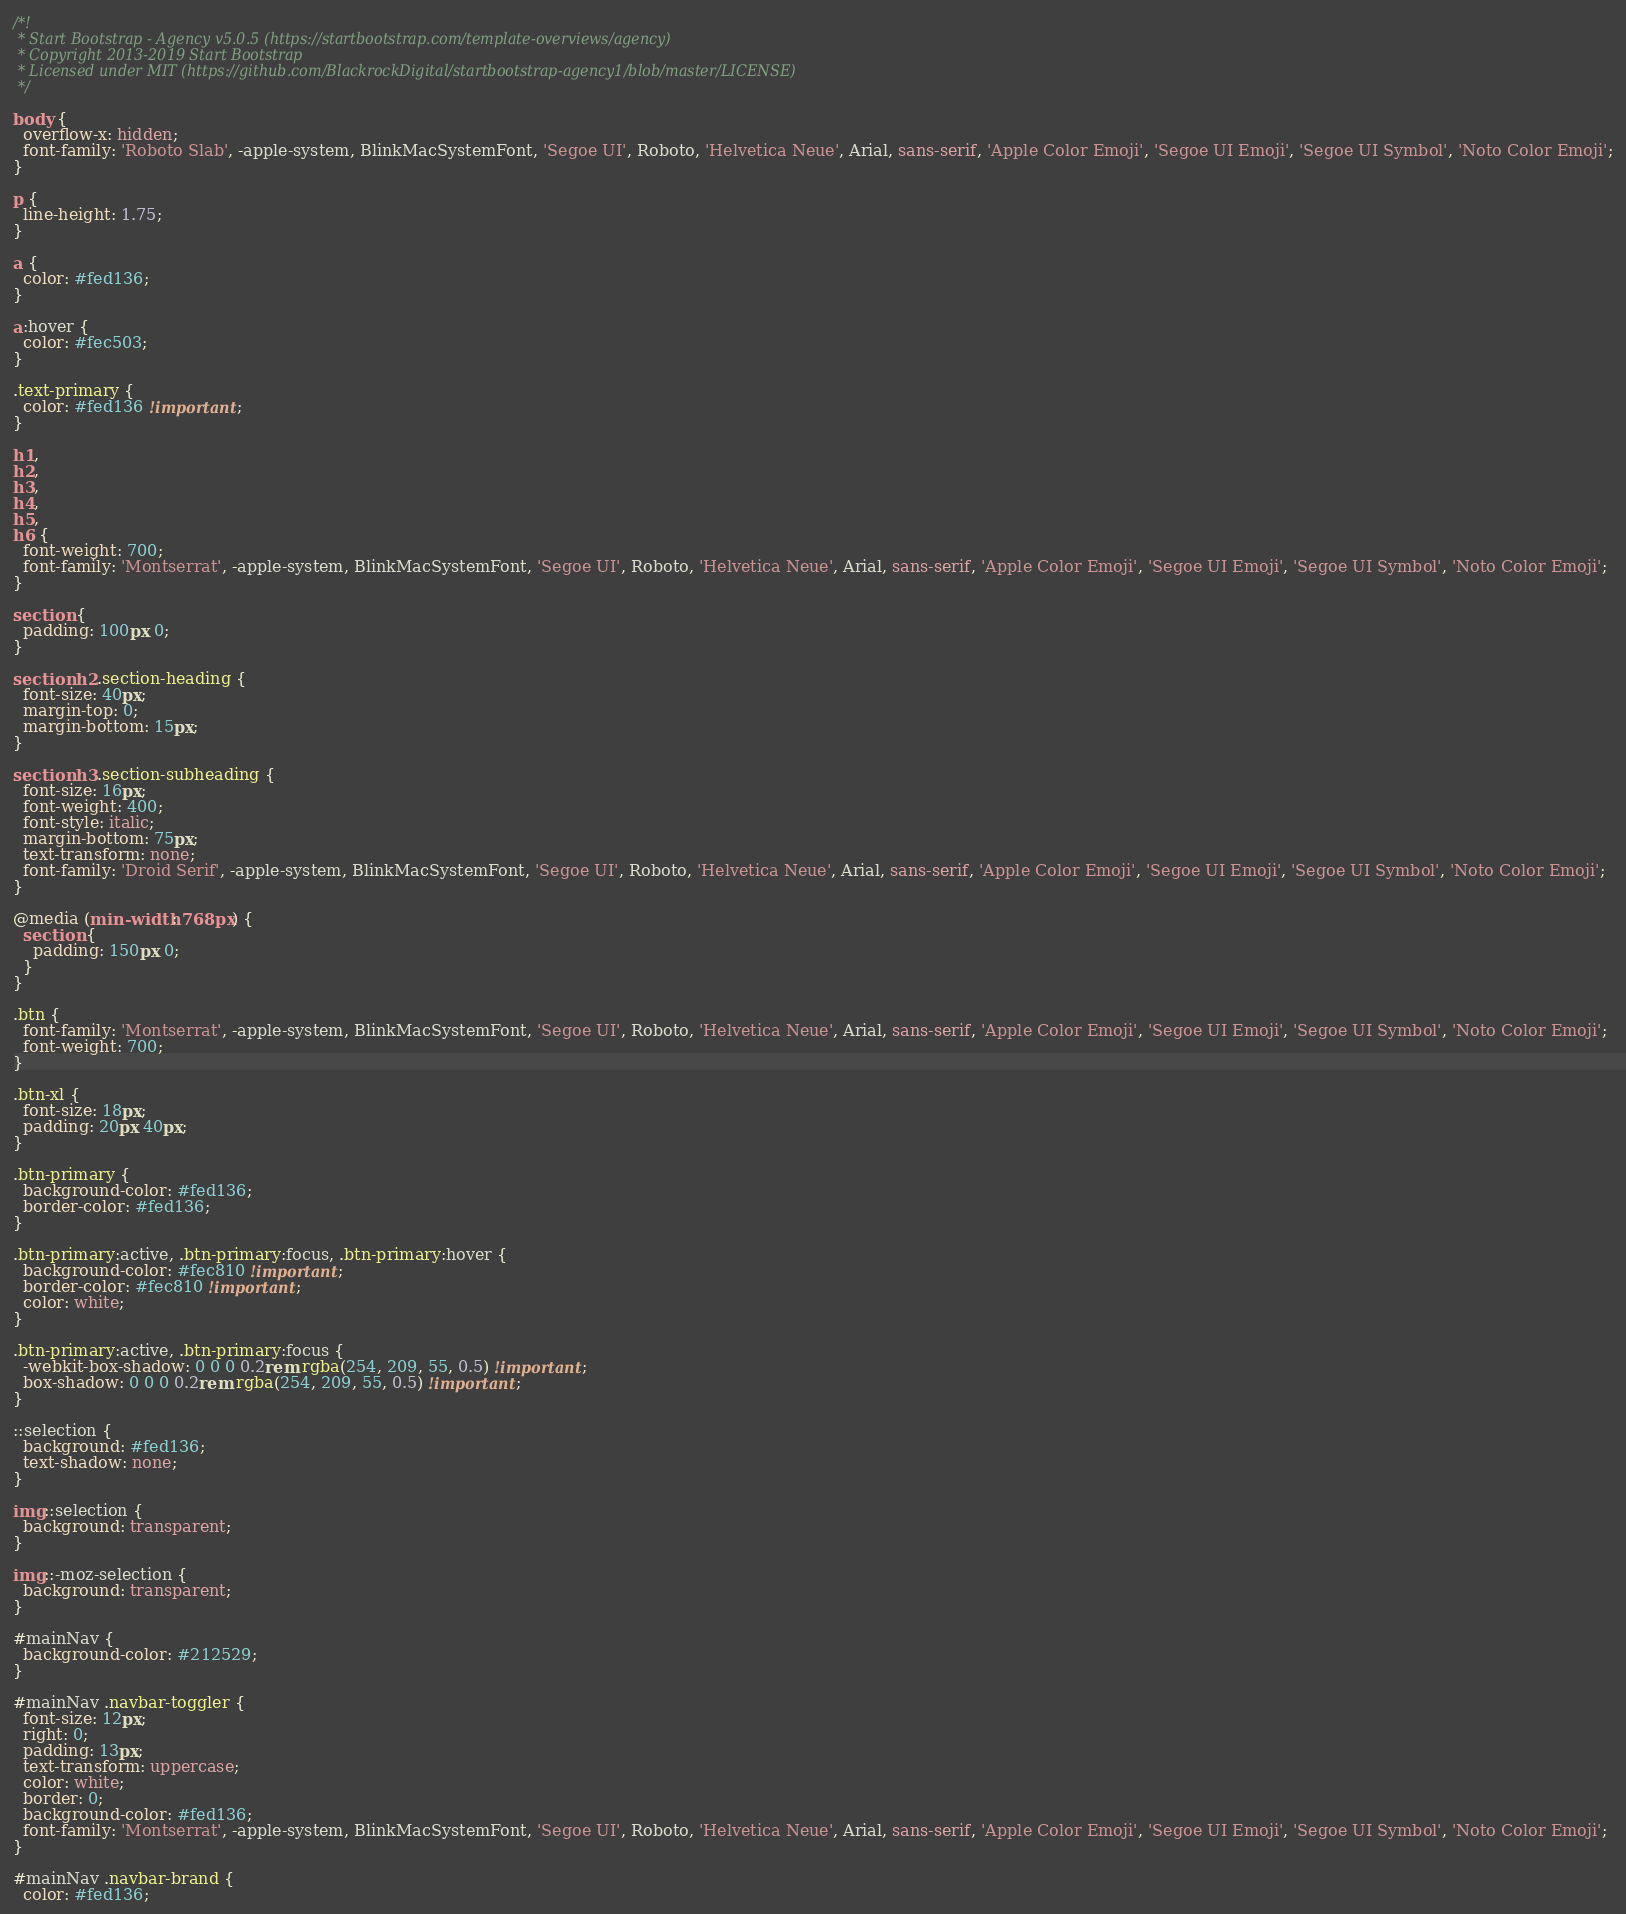<code> <loc_0><loc_0><loc_500><loc_500><_CSS_>/*!
 * Start Bootstrap - Agency v5.0.5 (https://startbootstrap.com/template-overviews/agency)
 * Copyright 2013-2019 Start Bootstrap
 * Licensed under MIT (https://github.com/BlackrockDigital/startbootstrap-agency1/blob/master/LICENSE)
 */

body {
  overflow-x: hidden;
  font-family: 'Roboto Slab', -apple-system, BlinkMacSystemFont, 'Segoe UI', Roboto, 'Helvetica Neue', Arial, sans-serif, 'Apple Color Emoji', 'Segoe UI Emoji', 'Segoe UI Symbol', 'Noto Color Emoji';
}

p {
  line-height: 1.75;
}

a {
  color: #fed136;
}

a:hover {
  color: #fec503;
}

.text-primary {
  color: #fed136 !important;
}

h1,
h2,
h3,
h4,
h5,
h6 {
  font-weight: 700;
  font-family: 'Montserrat', -apple-system, BlinkMacSystemFont, 'Segoe UI', Roboto, 'Helvetica Neue', Arial, sans-serif, 'Apple Color Emoji', 'Segoe UI Emoji', 'Segoe UI Symbol', 'Noto Color Emoji';
}

section {
  padding: 100px 0;
}

section h2.section-heading {
  font-size: 40px;
  margin-top: 0;
  margin-bottom: 15px;
}

section h3.section-subheading {
  font-size: 16px;
  font-weight: 400;
  font-style: italic;
  margin-bottom: 75px;
  text-transform: none;
  font-family: 'Droid Serif', -apple-system, BlinkMacSystemFont, 'Segoe UI', Roboto, 'Helvetica Neue', Arial, sans-serif, 'Apple Color Emoji', 'Segoe UI Emoji', 'Segoe UI Symbol', 'Noto Color Emoji';
}

@media (min-width: 768px) {
  section {
    padding: 150px 0;
  }
}

.btn {
  font-family: 'Montserrat', -apple-system, BlinkMacSystemFont, 'Segoe UI', Roboto, 'Helvetica Neue', Arial, sans-serif, 'Apple Color Emoji', 'Segoe UI Emoji', 'Segoe UI Symbol', 'Noto Color Emoji';
  font-weight: 700;
}

.btn-xl {
  font-size: 18px;
  padding: 20px 40px;
}

.btn-primary {
  background-color: #fed136;
  border-color: #fed136;
}

.btn-primary:active, .btn-primary:focus, .btn-primary:hover {
  background-color: #fec810 !important;
  border-color: #fec810 !important;
  color: white;
}

.btn-primary:active, .btn-primary:focus {
  -webkit-box-shadow: 0 0 0 0.2rem rgba(254, 209, 55, 0.5) !important;
  box-shadow: 0 0 0 0.2rem rgba(254, 209, 55, 0.5) !important;
}

::selection {
  background: #fed136;
  text-shadow: none;
}

img::selection {
  background: transparent;
}

img::-moz-selection {
  background: transparent;
}

#mainNav {
  background-color: #212529;
}

#mainNav .navbar-toggler {
  font-size: 12px;
  right: 0;
  padding: 13px;
  text-transform: uppercase;
  color: white;
  border: 0;
  background-color: #fed136;
  font-family: 'Montserrat', -apple-system, BlinkMacSystemFont, 'Segoe UI', Roboto, 'Helvetica Neue', Arial, sans-serif, 'Apple Color Emoji', 'Segoe UI Emoji', 'Segoe UI Symbol', 'Noto Color Emoji';
}

#mainNav .navbar-brand {
  color: #fed136;</code> 